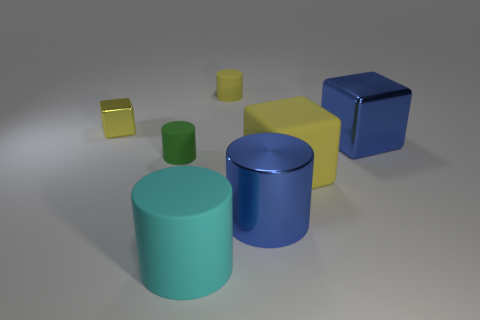Is the material of the blue object left of the big yellow rubber block the same as the yellow cylinder?
Make the answer very short. No. Are there the same number of large blue cylinders in front of the large blue metallic cube and objects in front of the big metallic cylinder?
Provide a succinct answer. Yes. The small thing that is both to the right of the small yellow cube and in front of the yellow cylinder has what shape?
Your response must be concise. Cylinder. There is a metallic cylinder; what number of big yellow things are right of it?
Keep it short and to the point. 1. How many other objects are there of the same shape as the tiny green matte object?
Keep it short and to the point. 3. Are there fewer green rubber things than brown metallic blocks?
Make the answer very short. No. There is a yellow thing that is behind the blue shiny block and in front of the tiny yellow matte object; what size is it?
Ensure brevity in your answer.  Small. What size is the matte object in front of the large yellow block that is behind the big cyan cylinder in front of the small yellow cylinder?
Keep it short and to the point. Large. The green rubber cylinder has what size?
Your answer should be very brief. Small. Are there any other things that are made of the same material as the green thing?
Ensure brevity in your answer.  Yes. 